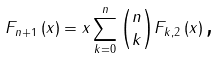Convert formula to latex. <formula><loc_0><loc_0><loc_500><loc_500>F _ { n + 1 } \left ( x \right ) = x \sum _ { k = 0 } ^ { n } \binom { n } { k } F _ { k , 2 } \left ( x \right ) \text {,}</formula> 